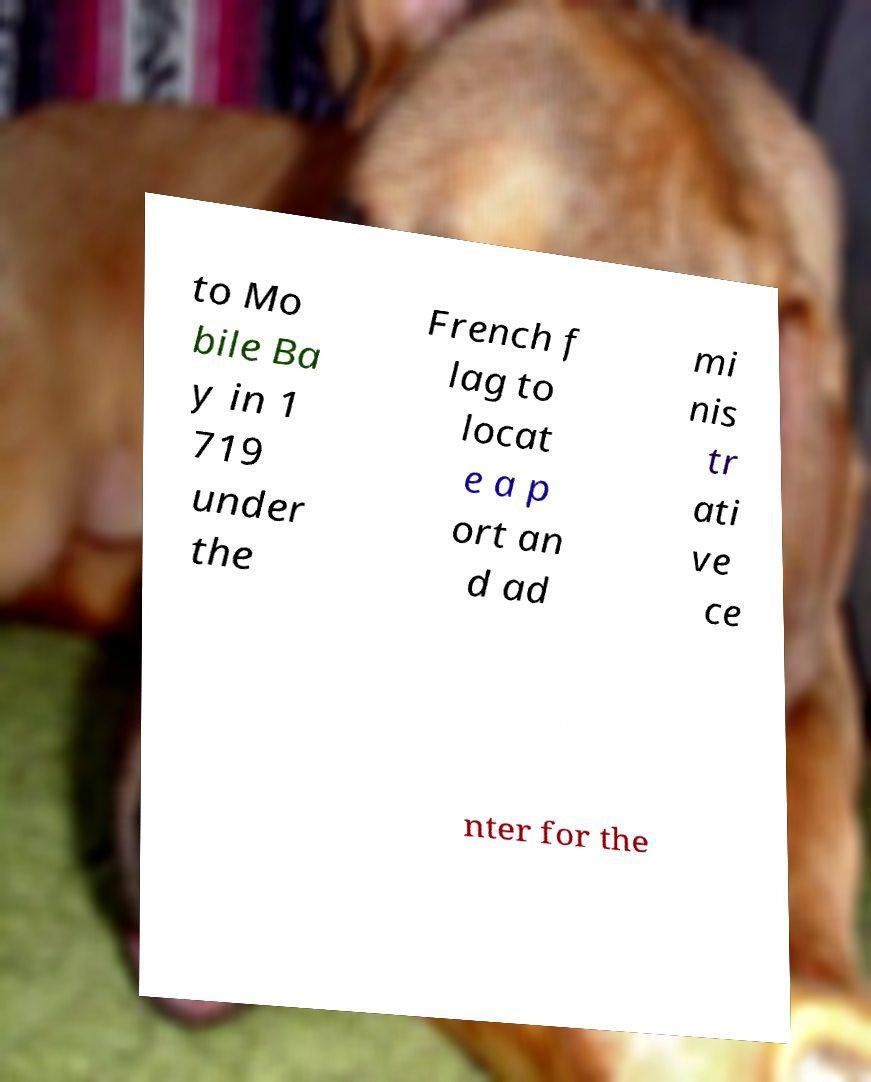Please identify and transcribe the text found in this image. to Mo bile Ba y in 1 719 under the French f lag to locat e a p ort an d ad mi nis tr ati ve ce nter for the 